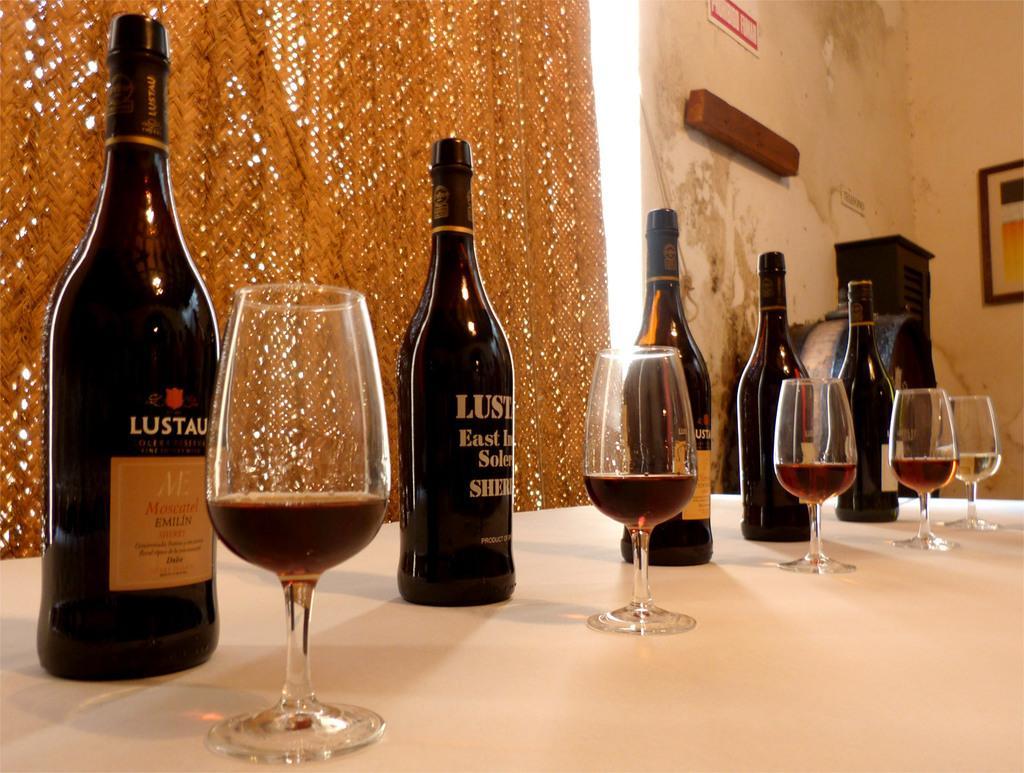How would you summarize this image in a sentence or two? In this picture i could see a wine bottles and wine glass beside them filled with wine arranged in a row in the background i could see a brown colored curtain and a wall and a picture frame. 